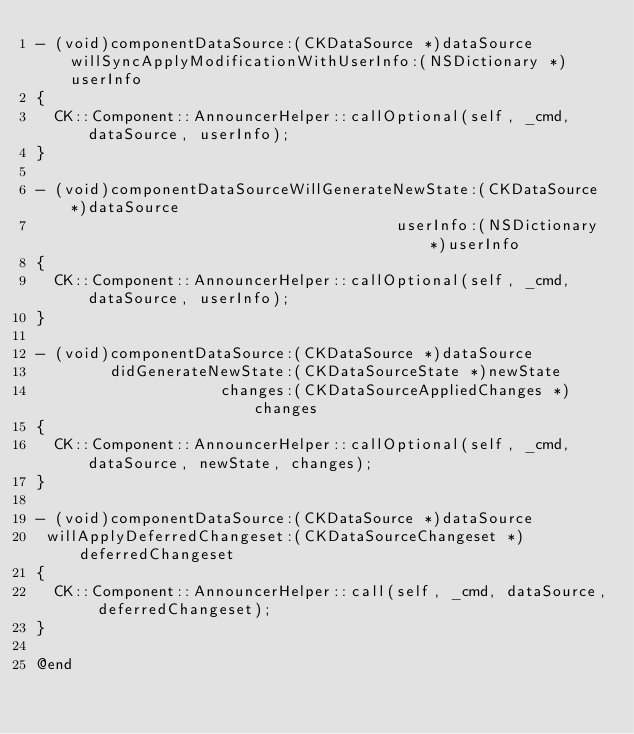Convert code to text. <code><loc_0><loc_0><loc_500><loc_500><_ObjectiveC_>- (void)componentDataSource:(CKDataSource *)dataSource willSyncApplyModificationWithUserInfo:(NSDictionary *)userInfo
{
  CK::Component::AnnouncerHelper::callOptional(self, _cmd, dataSource, userInfo);
}

- (void)componentDataSourceWillGenerateNewState:(CKDataSource *)dataSource
                                       userInfo:(NSDictionary *)userInfo
{
  CK::Component::AnnouncerHelper::callOptional(self, _cmd, dataSource, userInfo);
}

- (void)componentDataSource:(CKDataSource *)dataSource
        didGenerateNewState:(CKDataSourceState *)newState
                    changes:(CKDataSourceAppliedChanges *)changes
{
  CK::Component::AnnouncerHelper::callOptional(self, _cmd, dataSource, newState, changes);
}

- (void)componentDataSource:(CKDataSource *)dataSource
 willApplyDeferredChangeset:(CKDataSourceChangeset *)deferredChangeset
{
  CK::Component::AnnouncerHelper::call(self, _cmd, dataSource, deferredChangeset);
}

@end
</code> 